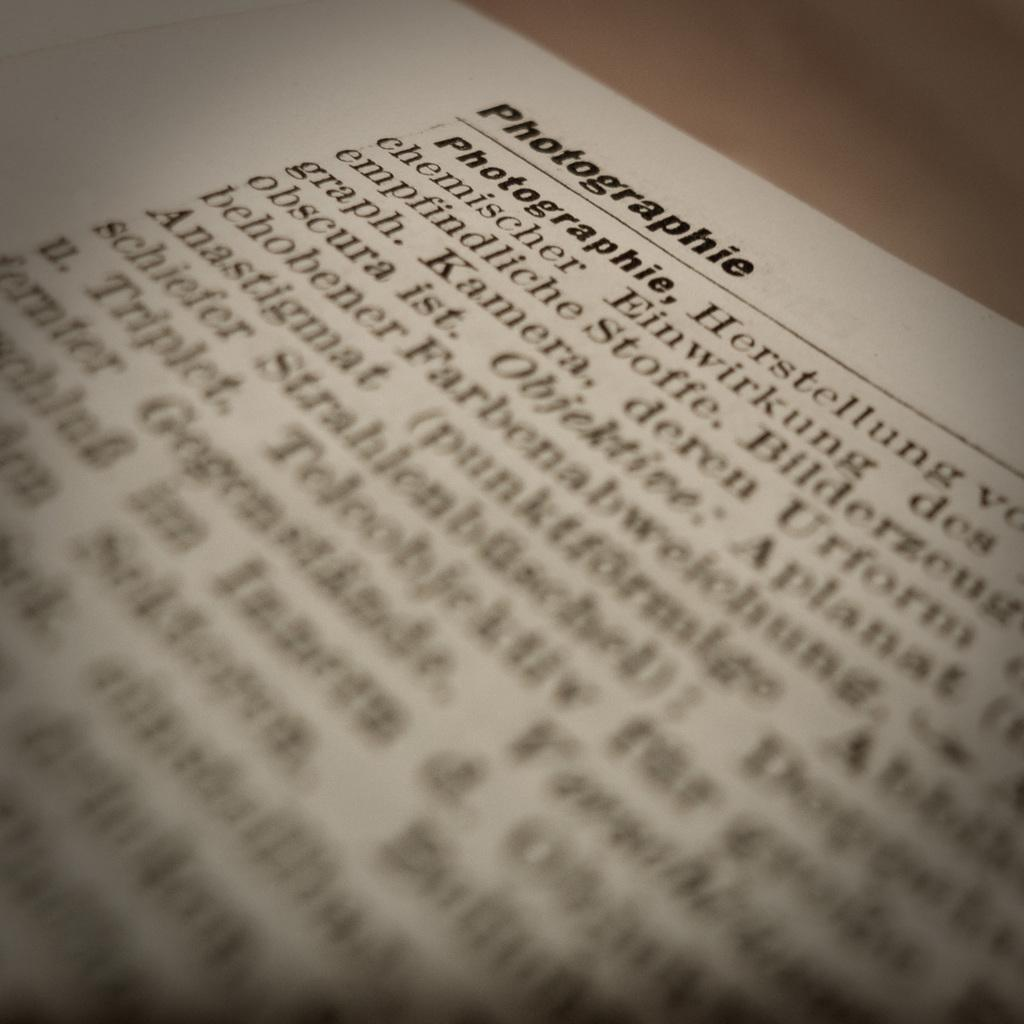<image>
Share a concise interpretation of the image provided. a typed page with the word 'photographie' at the top 